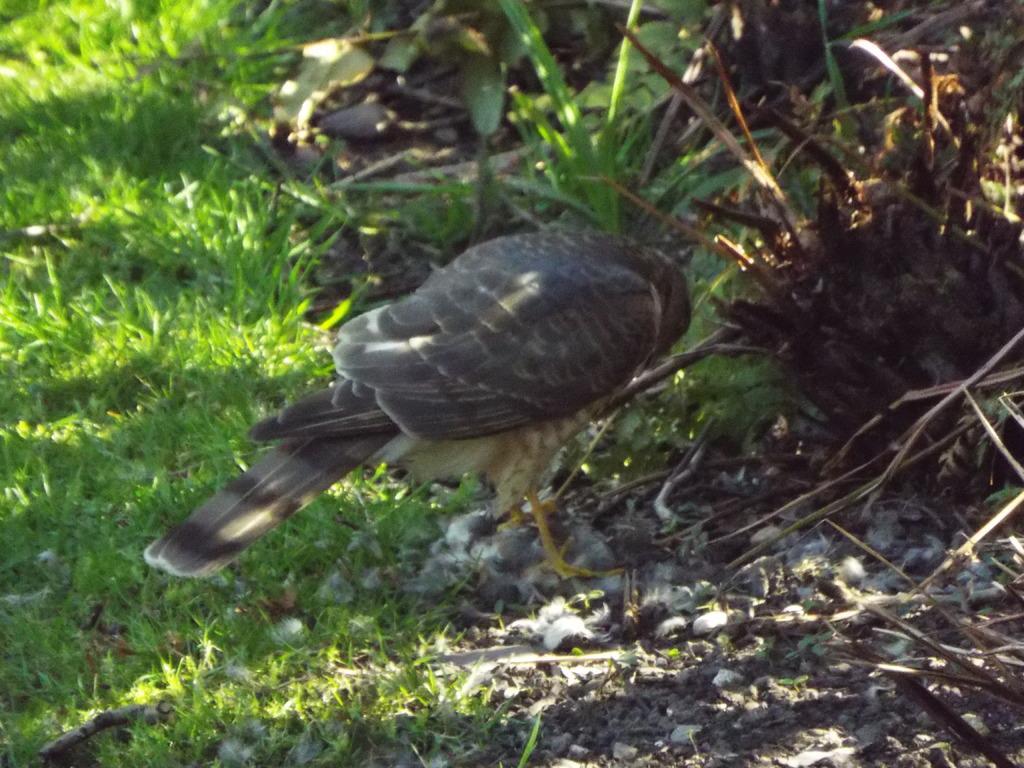Please provide a concise description of this image. In this image we can see a grey and black color bird is standing on the land. Left side of the image grass is present. 